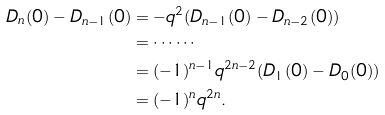<formula> <loc_0><loc_0><loc_500><loc_500>D _ { n } ( 0 ) - D _ { n - 1 } ( 0 ) & = - q ^ { 2 } ( D _ { n - 1 } ( 0 ) - D _ { n - 2 } ( 0 ) ) \\ & = \cdots \cdots \\ & = ( - 1 ) ^ { n - 1 } q ^ { 2 n - 2 } ( D _ { 1 } ( 0 ) - D _ { 0 } ( 0 ) ) \\ & = ( - 1 ) ^ { n } q ^ { 2 n } .</formula> 